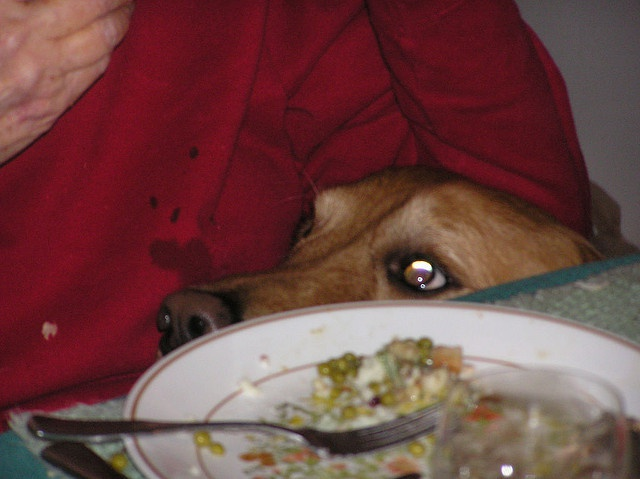Describe the objects in this image and their specific colors. I can see people in brown, maroon, black, and salmon tones, dog in brown, maroon, black, and gray tones, wine glass in brown, gray, darkgray, and maroon tones, dining table in brown, gray, teal, black, and purple tones, and fork in brown, black, and gray tones in this image. 